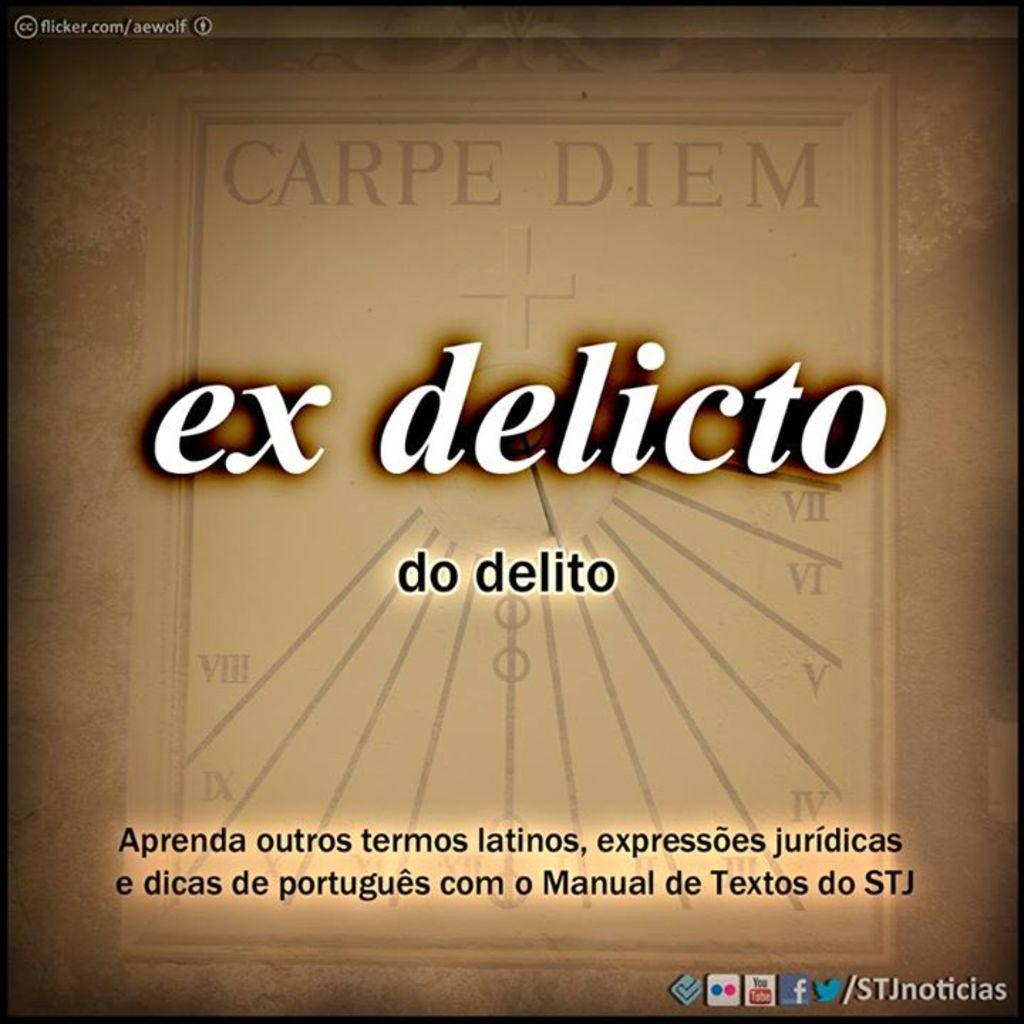<image>
Summarize the visual content of the image. A brown image contains the term "carpe diem". 